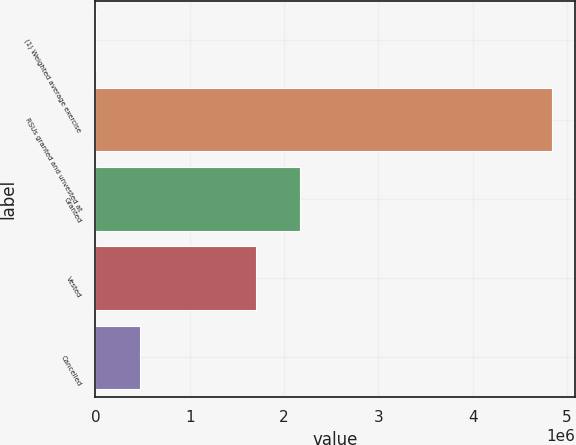Convert chart to OTSL. <chart><loc_0><loc_0><loc_500><loc_500><bar_chart><fcel>(1) Weighted average exercise<fcel>RSUs granted and unvested at<fcel>Granted<fcel>Vested<fcel>Cancelled<nl><fcel>2012<fcel>4.84089e+06<fcel>2.17454e+06<fcel>1.70462e+06<fcel>471923<nl></chart> 